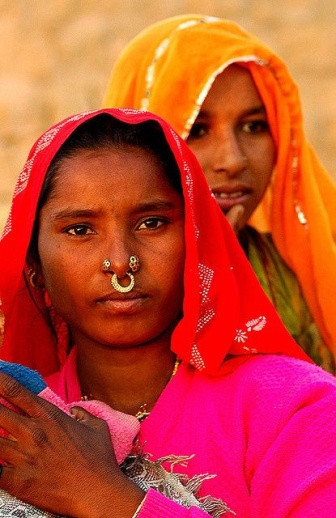Can you describe the facial expressions of the women in the image? The facial expression of the woman in the foreground appears serene yet strong, reflecting a deep sense of cultural pride, as she gazes directly at the camera. Her eyes convey a sense of resilience and confidence. The woman in the background has a softer, more contemplative expression as she looks into the distance, adding a layer of introspection and thoughtfulness to the scene. 